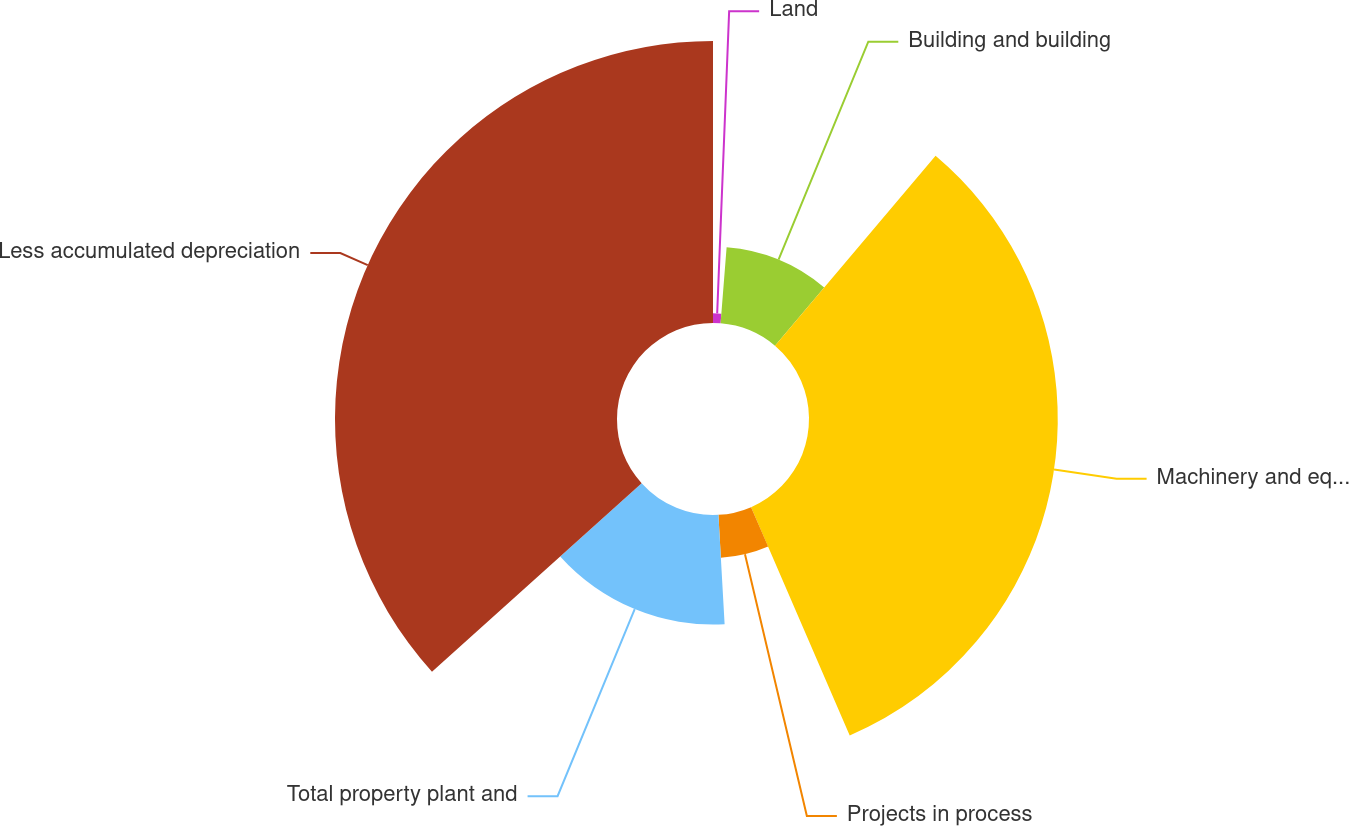<chart> <loc_0><loc_0><loc_500><loc_500><pie_chart><fcel>Land<fcel>Building and building<fcel>Machinery and equipment<fcel>Projects in process<fcel>Total property plant and<fcel>Less accumulated depreciation<nl><fcel>1.26%<fcel>9.91%<fcel>32.34%<fcel>5.59%<fcel>14.24%<fcel>36.66%<nl></chart> 